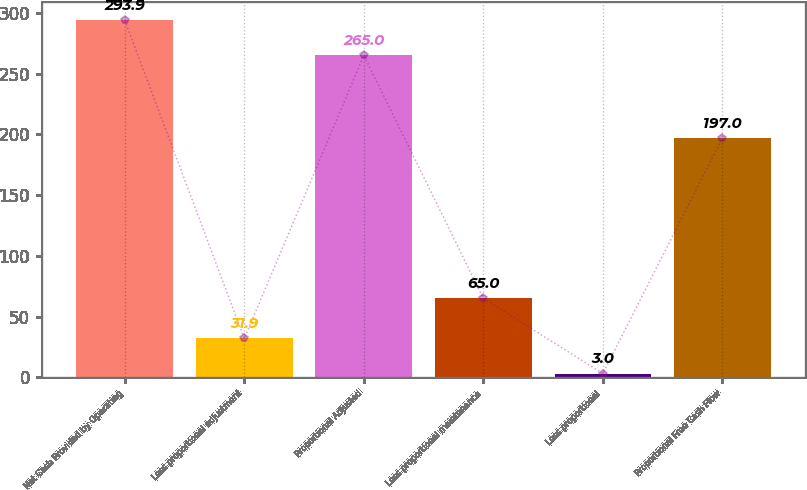<chart> <loc_0><loc_0><loc_500><loc_500><bar_chart><fcel>Net Cash Provided by Operating<fcel>Less proportional adjustment<fcel>Proportional Adjusted<fcel>Less proportional maintenance<fcel>Less proportional<fcel>Proportional Free Cash Flow<nl><fcel>293.9<fcel>31.9<fcel>265<fcel>65<fcel>3<fcel>197<nl></chart> 